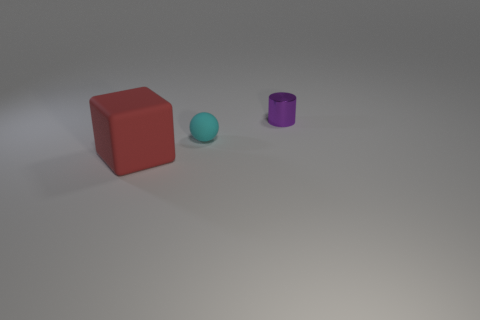Add 3 gray shiny spheres. How many objects exist? 6 Subtract all cubes. How many objects are left? 2 Add 1 big red rubber objects. How many big red rubber objects exist? 2 Subtract 0 purple balls. How many objects are left? 3 Subtract all big cyan metal spheres. Subtract all matte things. How many objects are left? 1 Add 3 purple things. How many purple things are left? 4 